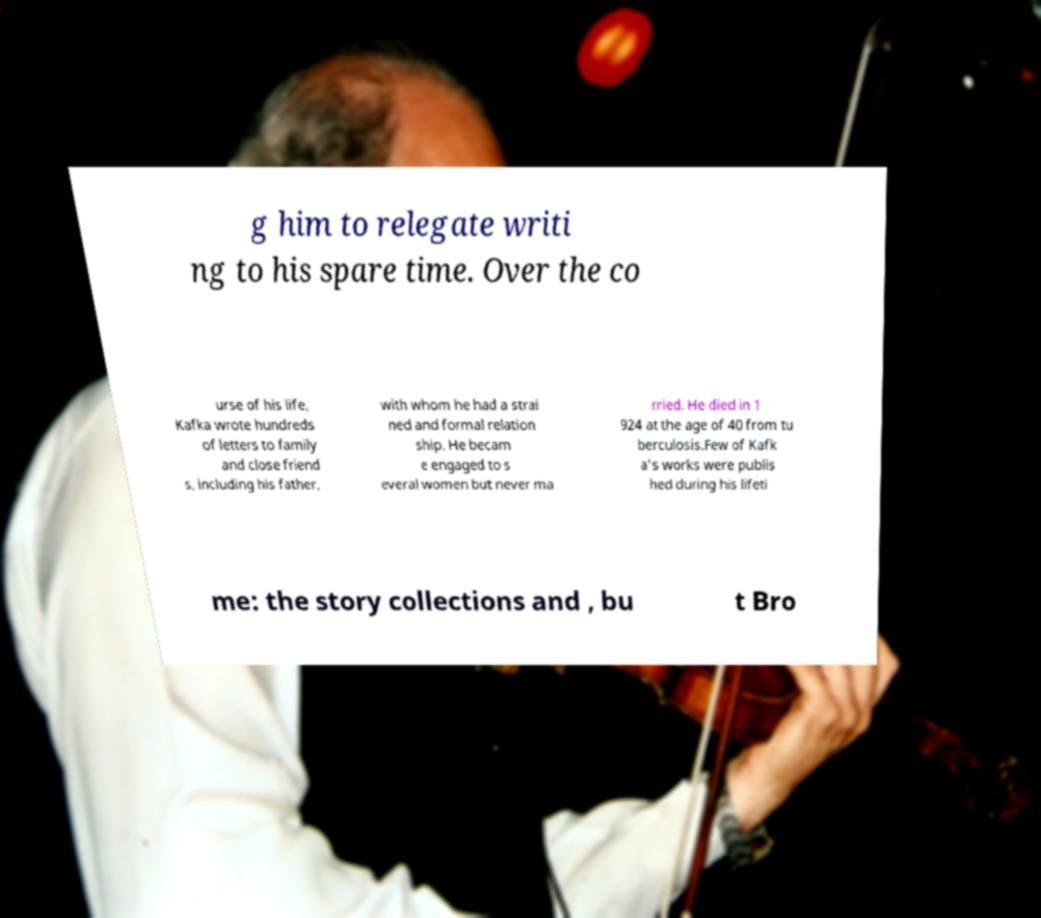I need the written content from this picture converted into text. Can you do that? g him to relegate writi ng to his spare time. Over the co urse of his life, Kafka wrote hundreds of letters to family and close friend s, including his father, with whom he had a strai ned and formal relation ship. He becam e engaged to s everal women but never ma rried. He died in 1 924 at the age of 40 from tu berculosis.Few of Kafk a's works were publis hed during his lifeti me: the story collections and , bu t Bro 